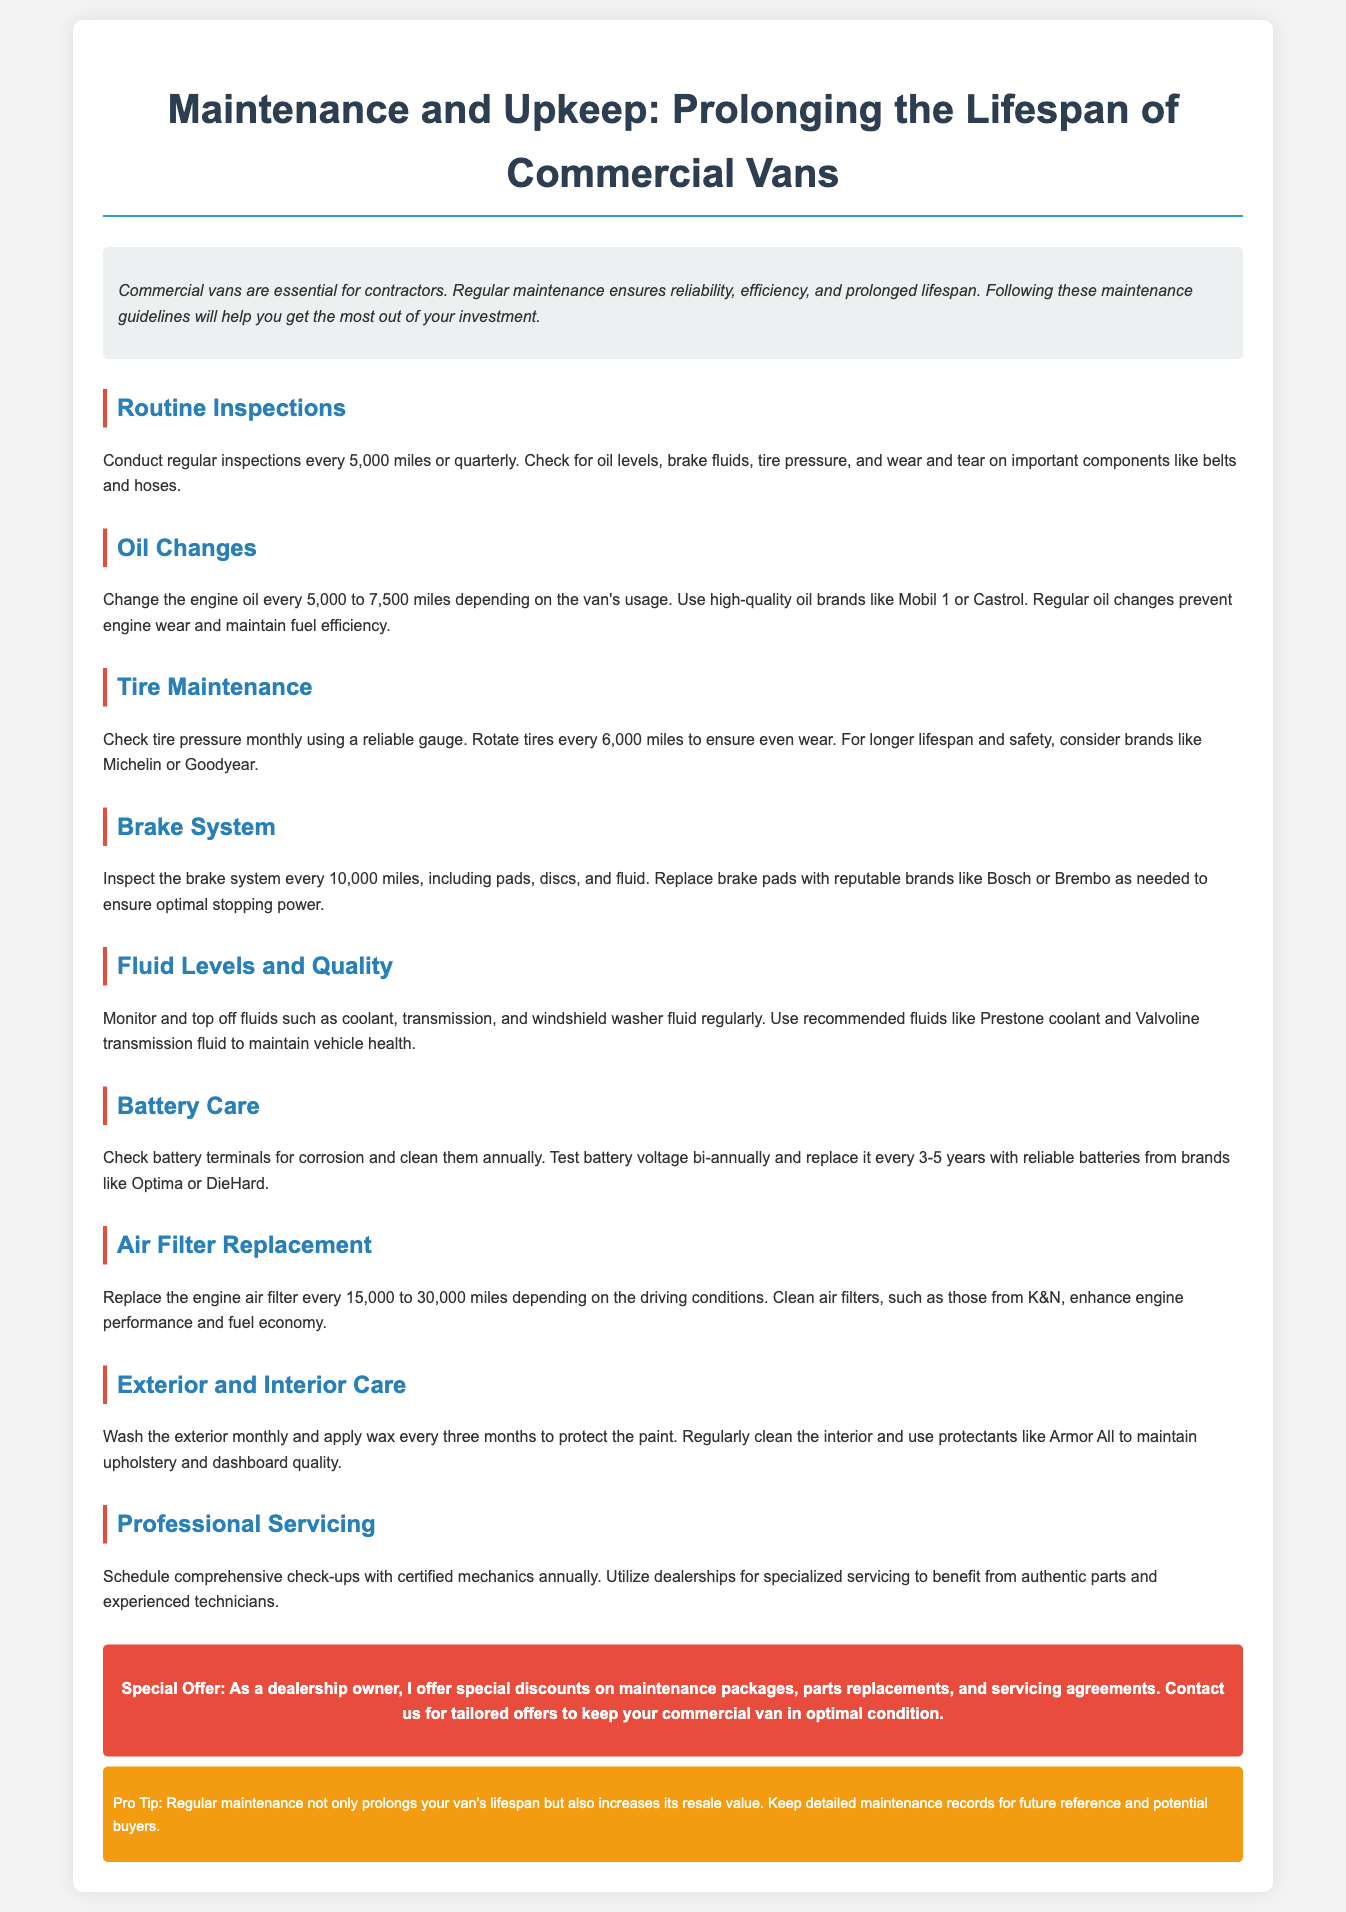what is the recommended frequency for routine inspections? Routine inspections should be conducted every 5,000 miles or quarterly.
Answer: every 5,000 miles or quarterly how often should engine oil be changed? The engine oil should be changed every 5,000 to 7,500 miles depending on usage.
Answer: every 5,000 to 7,500 miles what is the suggested tire maintenance interval for rotating tires? Tires should be rotated every 6,000 miles to ensure even wear.
Answer: every 6,000 miles which brands are recommended for brake pads? Recommended brands for brake pads are Bosch or Brembo.
Answer: Bosch or Brembo what fluid should be used for the coolant? Prestone is the recommended coolant to use.
Answer: Prestone what is a pro tip for maintaining resale value? Regular maintenance increases resale value and keeping detailed records is beneficial.
Answer: Keep detailed maintenance records how frequently should the battery be tested? The battery should be tested bi-annually.
Answer: bi-annually what maintenance action should be taken every three months for the exterior? The exterior should be waxed every three months.
Answer: wax every three months what is the purpose of professional servicing? Professional servicing provides comprehensive check-ups utilizing authentic parts and experienced technicians.
Answer: comprehensive check-ups 